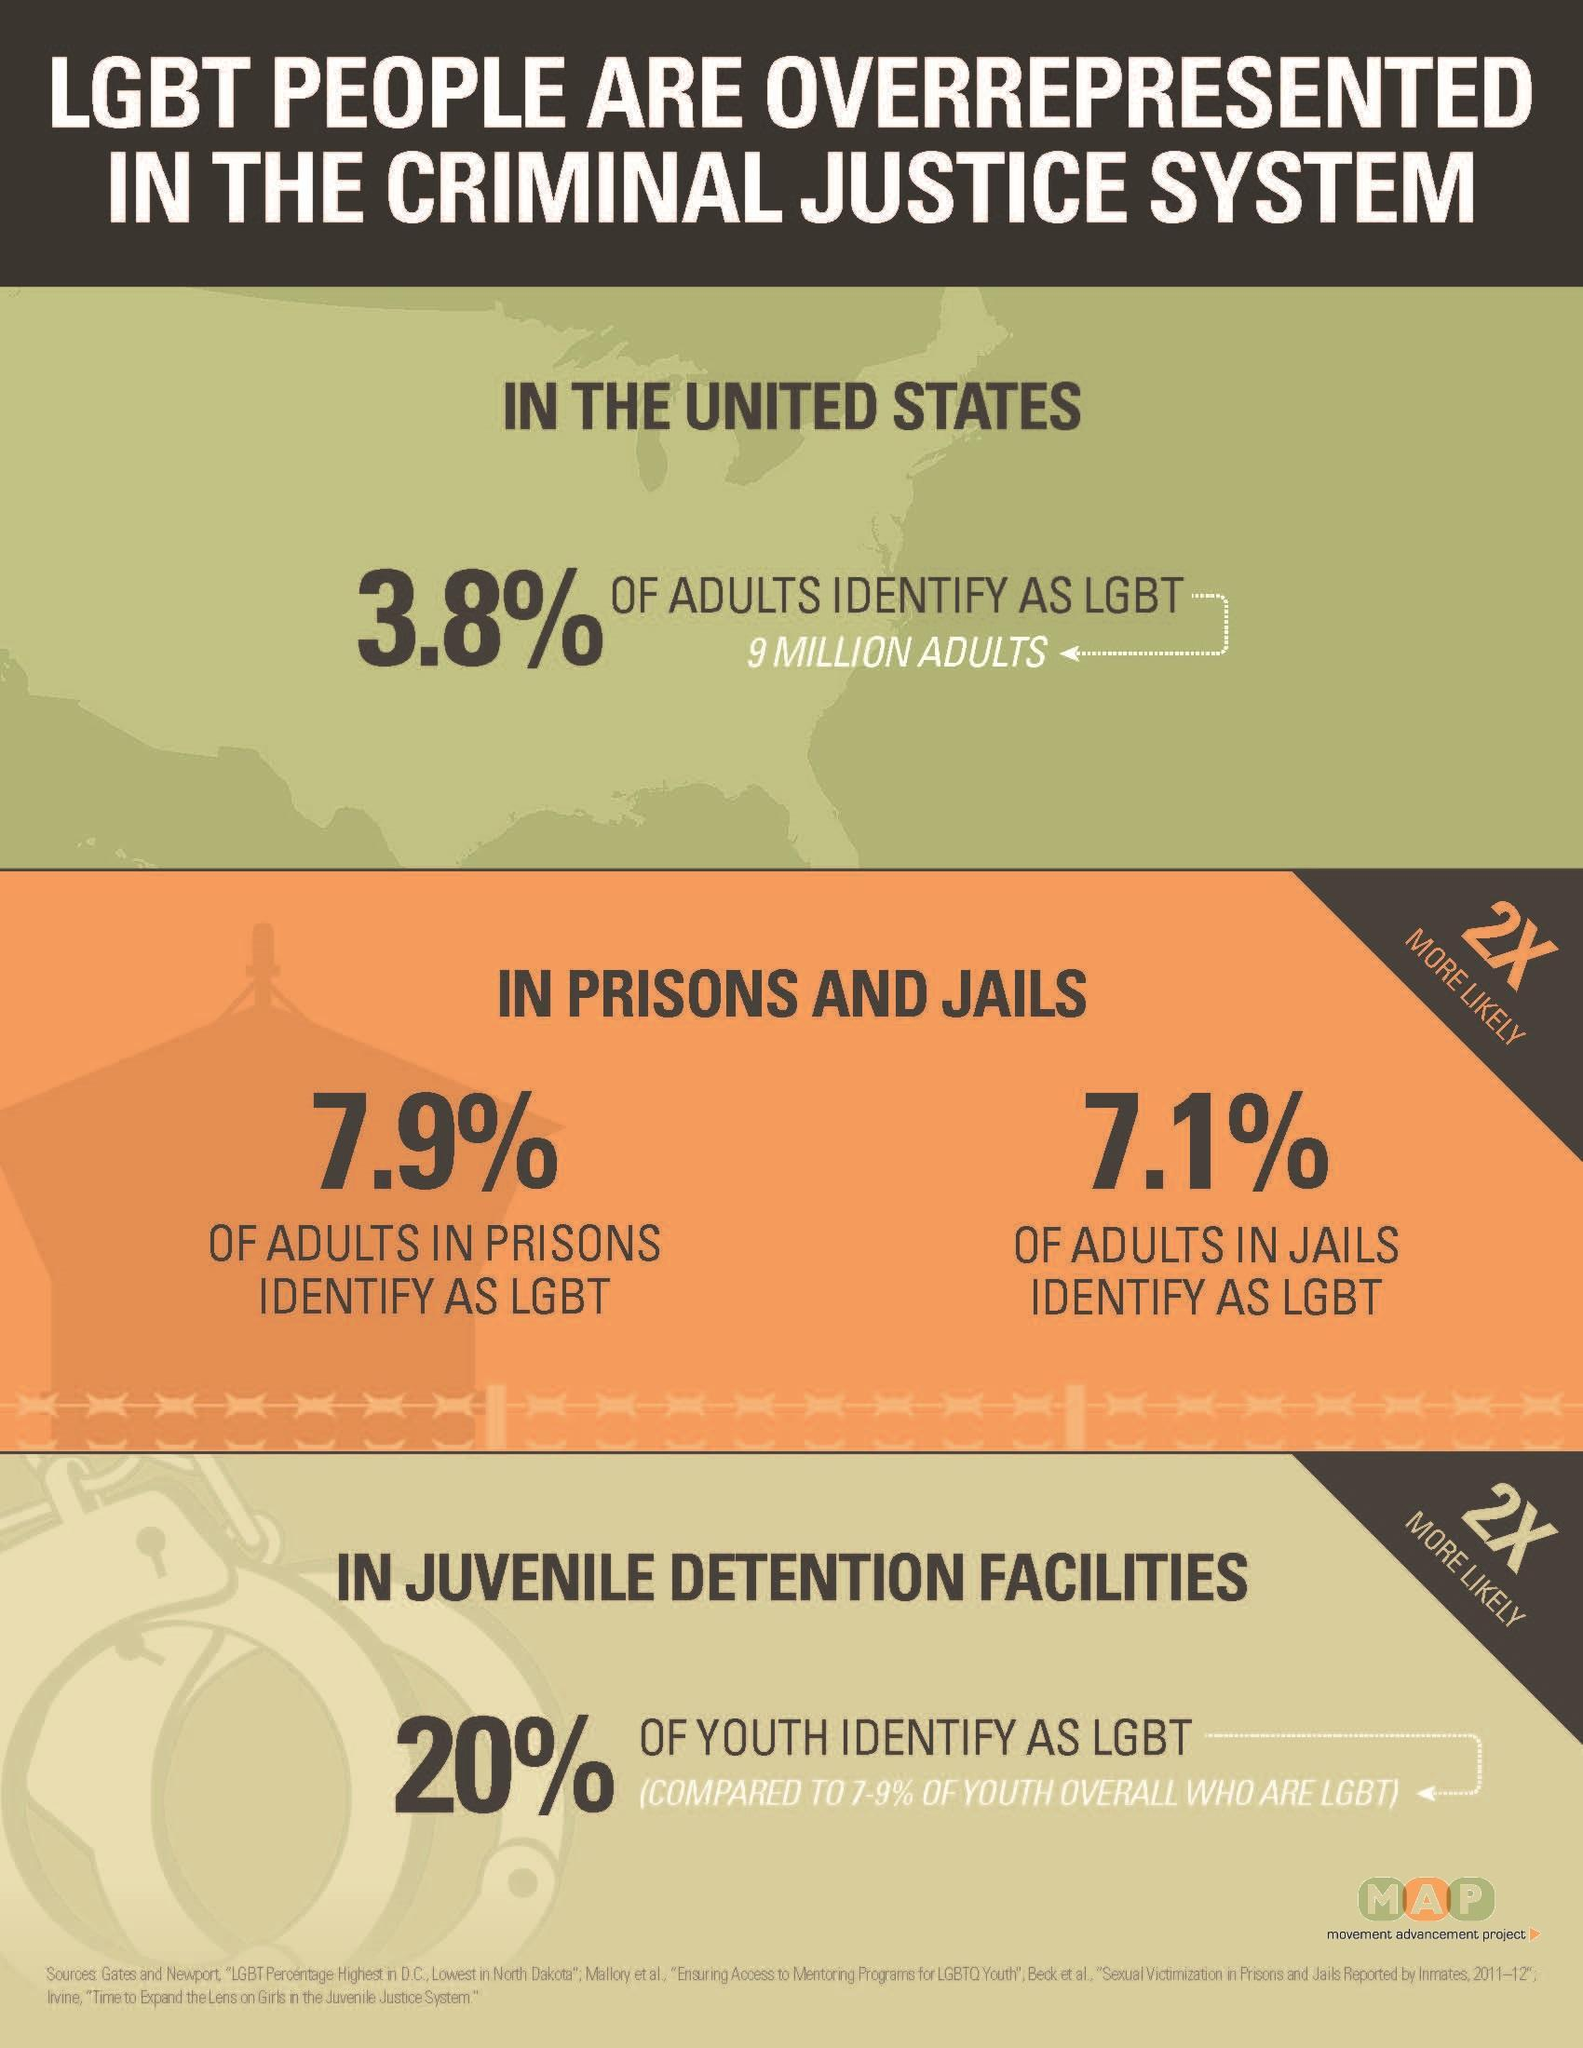What % of adults in prisons are LGBT
Answer the question with a short phrase. 7.9% What is the total percentage of LGBT adults in jails and prisons? 15% What percentage of LGBT are in detention centers for juveniles, 7.9%, 7.1%, or 20%? 20% 